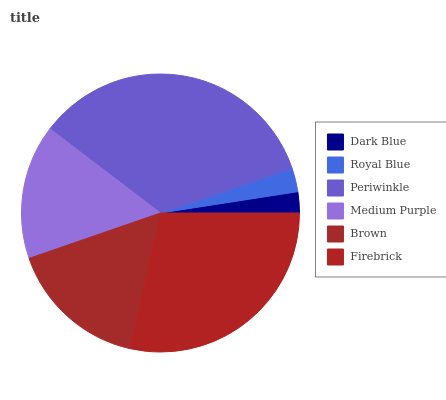Is Dark Blue the minimum?
Answer yes or no. Yes. Is Periwinkle the maximum?
Answer yes or no. Yes. Is Royal Blue the minimum?
Answer yes or no. No. Is Royal Blue the maximum?
Answer yes or no. No. Is Royal Blue greater than Dark Blue?
Answer yes or no. Yes. Is Dark Blue less than Royal Blue?
Answer yes or no. Yes. Is Dark Blue greater than Royal Blue?
Answer yes or no. No. Is Royal Blue less than Dark Blue?
Answer yes or no. No. Is Brown the high median?
Answer yes or no. Yes. Is Medium Purple the low median?
Answer yes or no. Yes. Is Royal Blue the high median?
Answer yes or no. No. Is Royal Blue the low median?
Answer yes or no. No. 